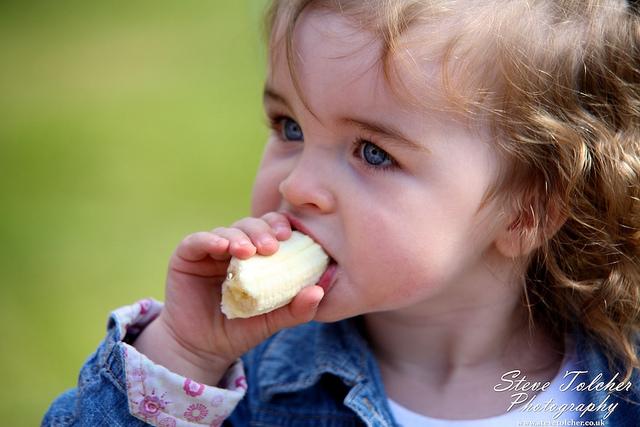What kind of fruit is the kid eating?
Give a very brief answer. Banana. What is the child eating?
Quick response, please. Banana. Is this girl eating healthy?
Give a very brief answer. Yes. Does the girl have brown eyes?
Concise answer only. No. 